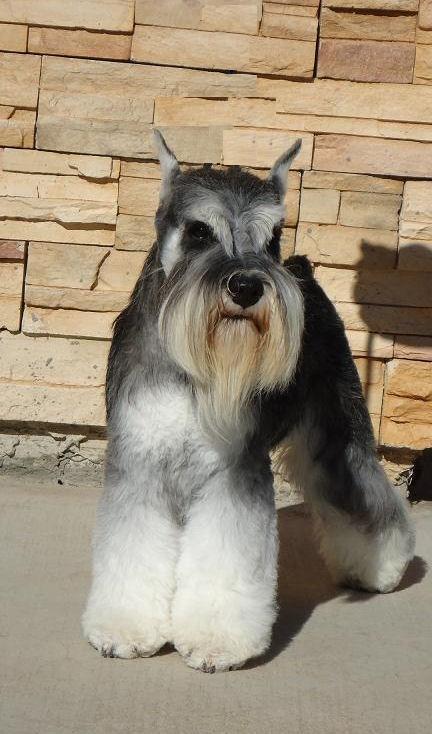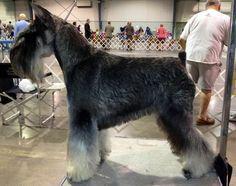The first image is the image on the left, the second image is the image on the right. Evaluate the accuracy of this statement regarding the images: "A dog is standing in front of a stone wall.". Is it true? Answer yes or no. Yes. The first image is the image on the left, the second image is the image on the right. Given the left and right images, does the statement "Right image shows a dog standing outdoors in profile, with body turned leftward." hold true? Answer yes or no. No. 